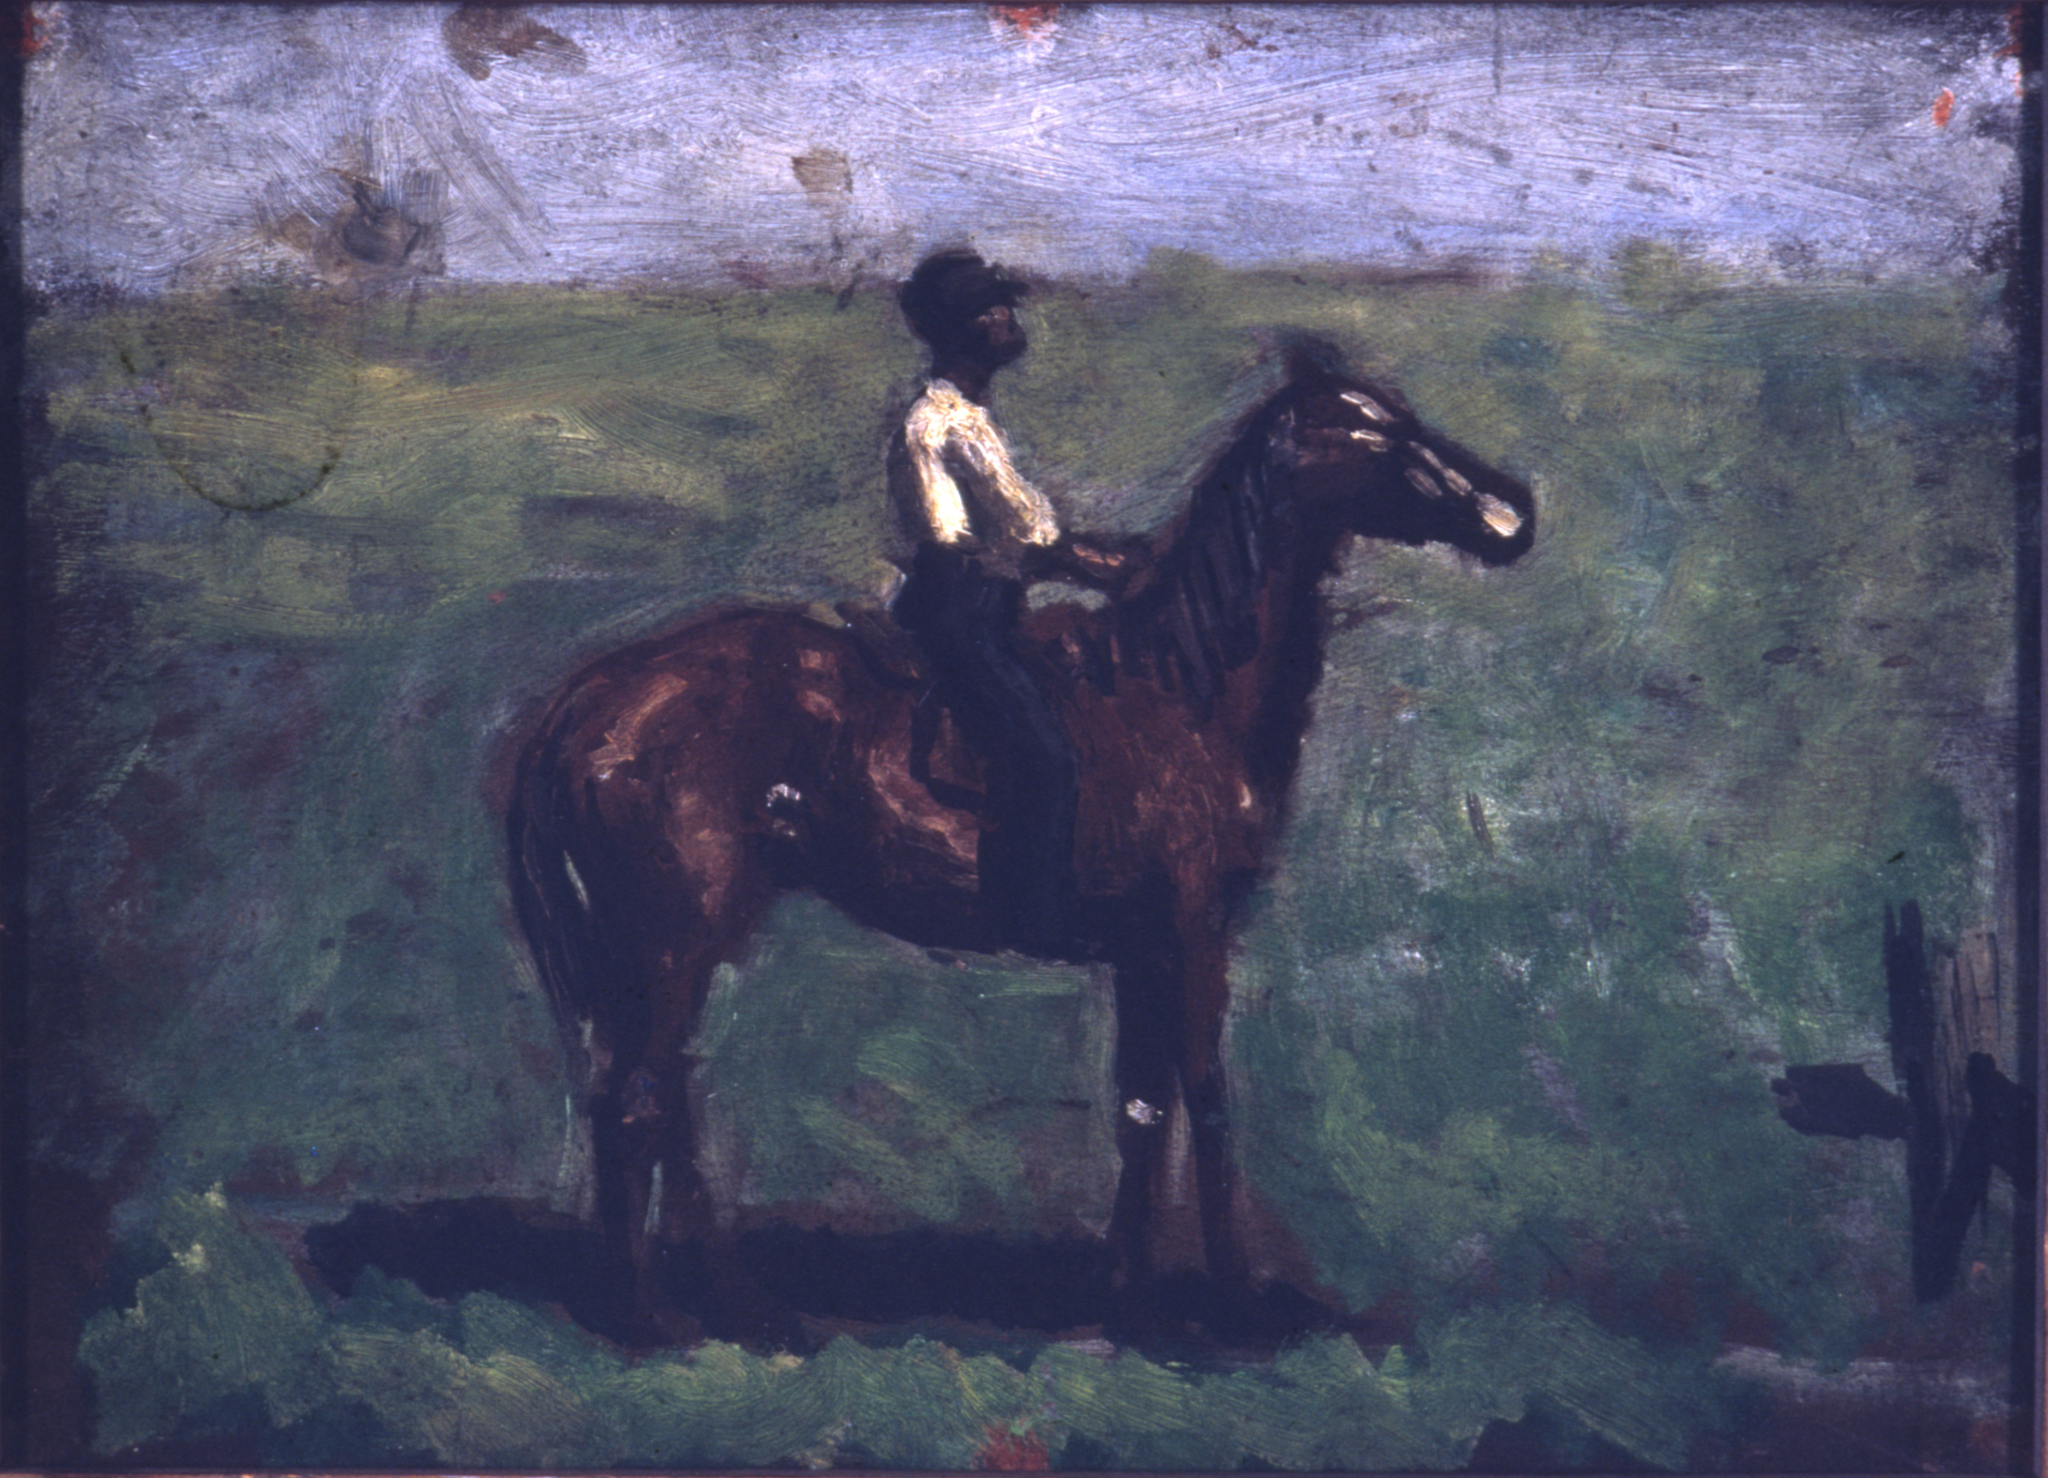Describe the following image. The image illustrates an impressionist painting of a man on horseback. The artistry is loose and sketchy, showcasing broad brushstrokes that are synonymous with the French impressionist movement. Dominated by hues of green and blue, the horse and rider stand out with their darker brown tones. The backdrop is a lush landscape replete with foliage under a serene blue sky. Such a depiction, with its emphasis on the impression of the scene rather than meticulous details, hints at an origin from the late 19th or early 20th century. By utilizing color and brush technique, the painter effectively communicates the dynamic movement of the horse and the calming ambiance of the surrounding nature. This artwork immerses viewers, inviting them to visualize themselves riding alongside the man, soaking in the natural beauty around them. 